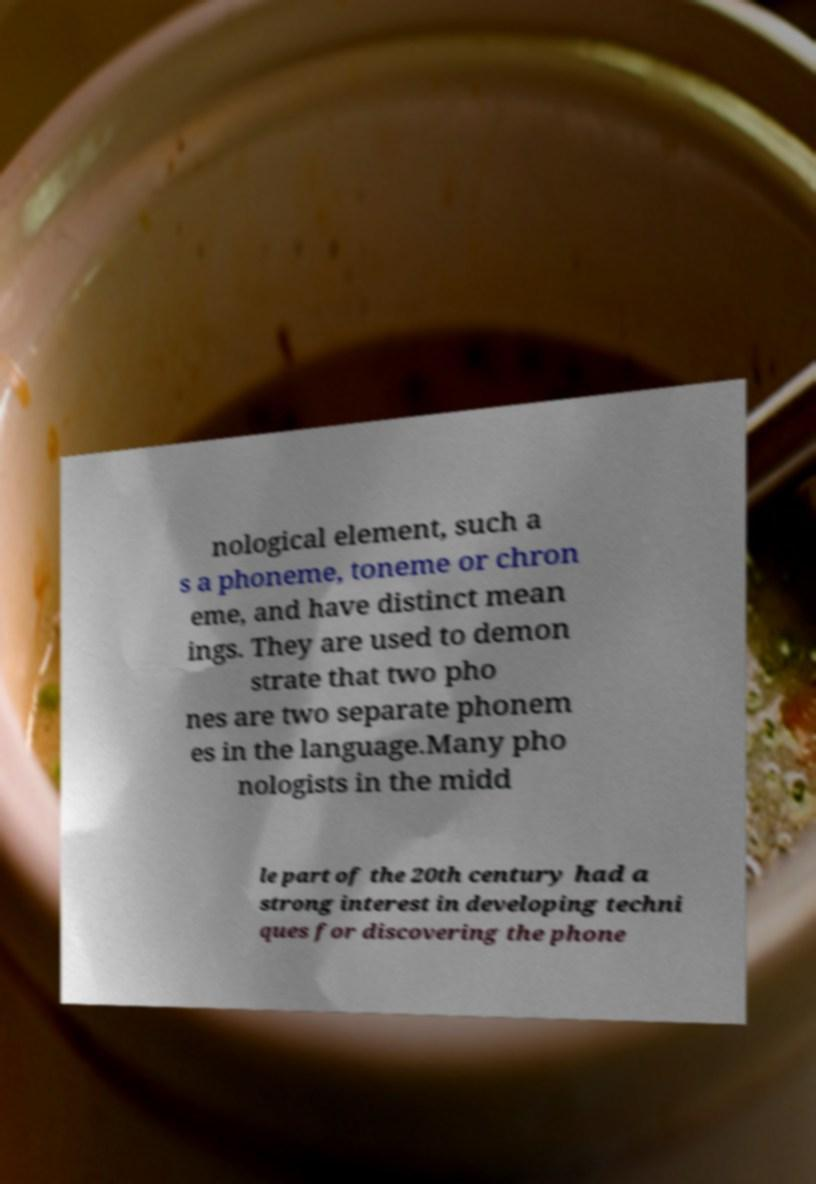Could you extract and type out the text from this image? nological element, such a s a phoneme, toneme or chron eme, and have distinct mean ings. They are used to demon strate that two pho nes are two separate phonem es in the language.Many pho nologists in the midd le part of the 20th century had a strong interest in developing techni ques for discovering the phone 